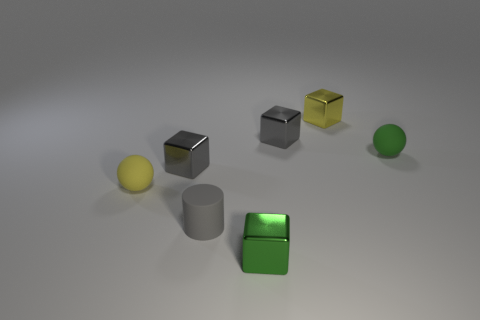Subtract all tiny yellow shiny cubes. How many cubes are left? 3 Subtract all green blocks. How many blocks are left? 3 Subtract 2 balls. How many balls are left? 0 Add 1 small green rubber balls. How many objects exist? 8 Subtract all cylinders. How many objects are left? 6 Subtract all gray blocks. How many cyan spheres are left? 0 Subtract all small yellow objects. Subtract all cyan shiny balls. How many objects are left? 5 Add 1 yellow blocks. How many yellow blocks are left? 2 Add 5 large purple rubber objects. How many large purple rubber objects exist? 5 Subtract 0 cyan cylinders. How many objects are left? 7 